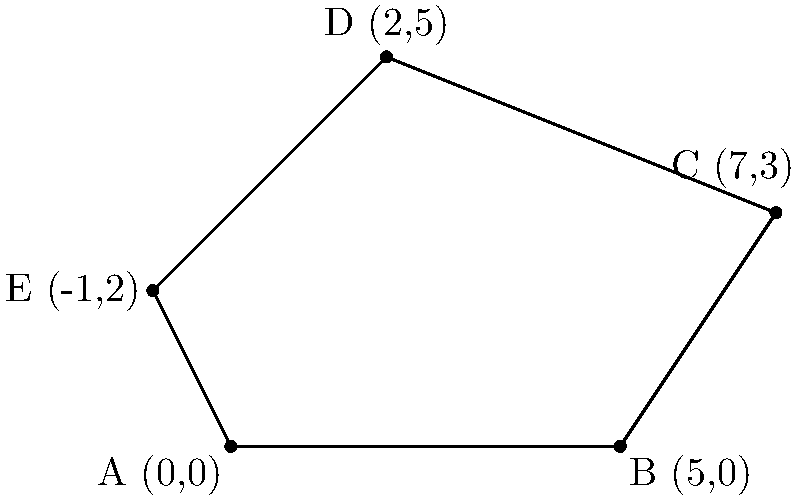As a construction contractor working on a government project, you need to calculate the perimeter of an irregularly shaped plot of land for fencing purposes. The plot is represented by a polygon with vertices at coordinates A(0,0), B(5,0), C(7,3), D(2,5), and E(-1,2). Calculate the perimeter of this plot to the nearest meter, assuming each unit on the coordinate system represents 10 meters. To calculate the perimeter, we need to find the sum of the distances between consecutive points, including the distance from the last point back to the first.

Step 1: Calculate the distance between each pair of consecutive points using the distance formula:
$d = \sqrt{(x_2-x_1)^2 + (y_2-y_1)^2}$

AB: $\sqrt{(5-0)^2 + (0-0)^2} = 5$
BC: $\sqrt{(7-5)^2 + (3-0)^2} = \sqrt{4 + 9} = \sqrt{13}$
CD: $\sqrt{(2-7)^2 + (5-3)^2} = \sqrt{25 + 4} = \sqrt{29}$
DE: $\sqrt{(-1-2)^2 + (2-5)^2} = \sqrt{9 + 9} = \sqrt{18} = 3\sqrt{2}$
EA: $\sqrt{(0+1)^2 + (0-2)^2} = \sqrt{1 + 4} = \sqrt{5}$

Step 2: Sum up all the distances:
$5 + \sqrt{13} + \sqrt{29} + 3\sqrt{2} + \sqrt{5}$

Step 3: Multiply by 10 to convert units to meters:
$10(5 + \sqrt{13} + \sqrt{29} + 3\sqrt{2} + \sqrt{5})$

Step 4: Calculate and round to the nearest meter:
$50 + 10\sqrt{13} + 10\sqrt{29} + 30\sqrt{2} + 10\sqrt{5} \approx 183.71$ meters

Therefore, the perimeter of the plot is approximately 184 meters.
Answer: 184 meters 